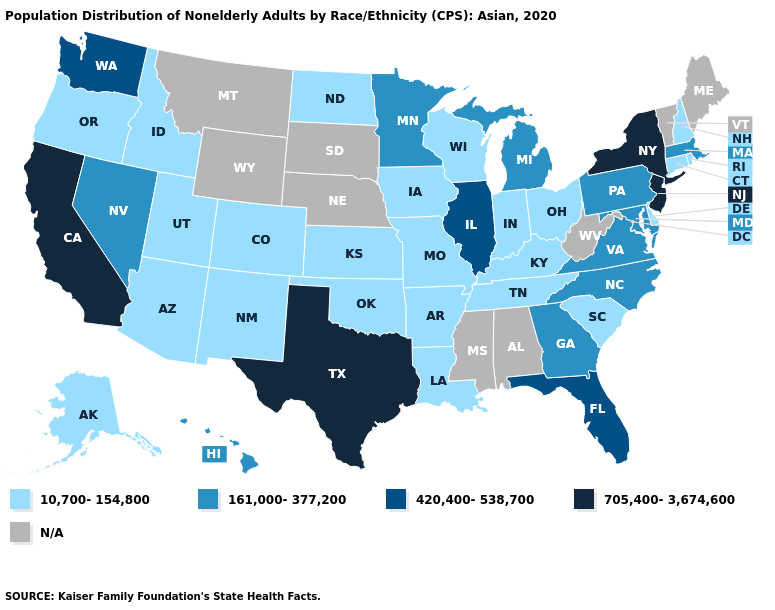What is the lowest value in the MidWest?
Be succinct. 10,700-154,800. Name the states that have a value in the range 161,000-377,200?
Quick response, please. Georgia, Hawaii, Maryland, Massachusetts, Michigan, Minnesota, Nevada, North Carolina, Pennsylvania, Virginia. Which states have the lowest value in the USA?
Short answer required. Alaska, Arizona, Arkansas, Colorado, Connecticut, Delaware, Idaho, Indiana, Iowa, Kansas, Kentucky, Louisiana, Missouri, New Hampshire, New Mexico, North Dakota, Ohio, Oklahoma, Oregon, Rhode Island, South Carolina, Tennessee, Utah, Wisconsin. What is the value of North Dakota?
Answer briefly. 10,700-154,800. What is the value of Arizona?
Be succinct. 10,700-154,800. Among the states that border Nebraska , which have the highest value?
Answer briefly. Colorado, Iowa, Kansas, Missouri. Name the states that have a value in the range 161,000-377,200?
Keep it brief. Georgia, Hawaii, Maryland, Massachusetts, Michigan, Minnesota, Nevada, North Carolina, Pennsylvania, Virginia. What is the lowest value in the USA?
Give a very brief answer. 10,700-154,800. Which states have the lowest value in the USA?
Write a very short answer. Alaska, Arizona, Arkansas, Colorado, Connecticut, Delaware, Idaho, Indiana, Iowa, Kansas, Kentucky, Louisiana, Missouri, New Hampshire, New Mexico, North Dakota, Ohio, Oklahoma, Oregon, Rhode Island, South Carolina, Tennessee, Utah, Wisconsin. Name the states that have a value in the range 420,400-538,700?
Be succinct. Florida, Illinois, Washington. Name the states that have a value in the range 420,400-538,700?
Write a very short answer. Florida, Illinois, Washington. Name the states that have a value in the range 420,400-538,700?
Concise answer only. Florida, Illinois, Washington. How many symbols are there in the legend?
Short answer required. 5. Name the states that have a value in the range 420,400-538,700?
Quick response, please. Florida, Illinois, Washington. 